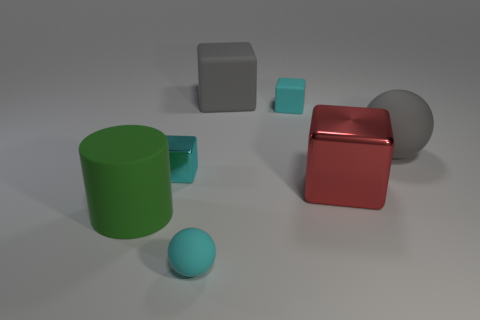How many cyan blocks must be subtracted to get 1 cyan blocks? 1 Subtract all small cyan matte blocks. How many blocks are left? 3 Subtract all cylinders. How many objects are left? 6 Add 2 big cyan shiny spheres. How many objects exist? 9 Subtract all gray blocks. How many blocks are left? 3 Subtract 1 cylinders. How many cylinders are left? 0 Add 7 shiny things. How many shiny things are left? 9 Add 5 small cyan matte cubes. How many small cyan matte cubes exist? 6 Subtract 1 gray spheres. How many objects are left? 6 Subtract all red cylinders. Subtract all yellow blocks. How many cylinders are left? 1 